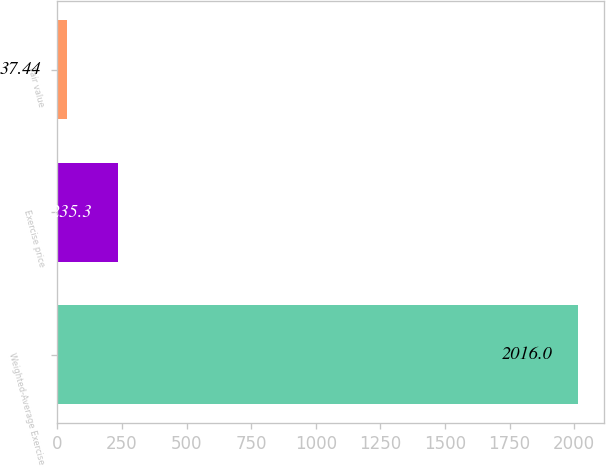<chart> <loc_0><loc_0><loc_500><loc_500><bar_chart><fcel>Weighted-Average Exercise<fcel>Exercise price<fcel>Fair value<nl><fcel>2016<fcel>235.3<fcel>37.44<nl></chart> 